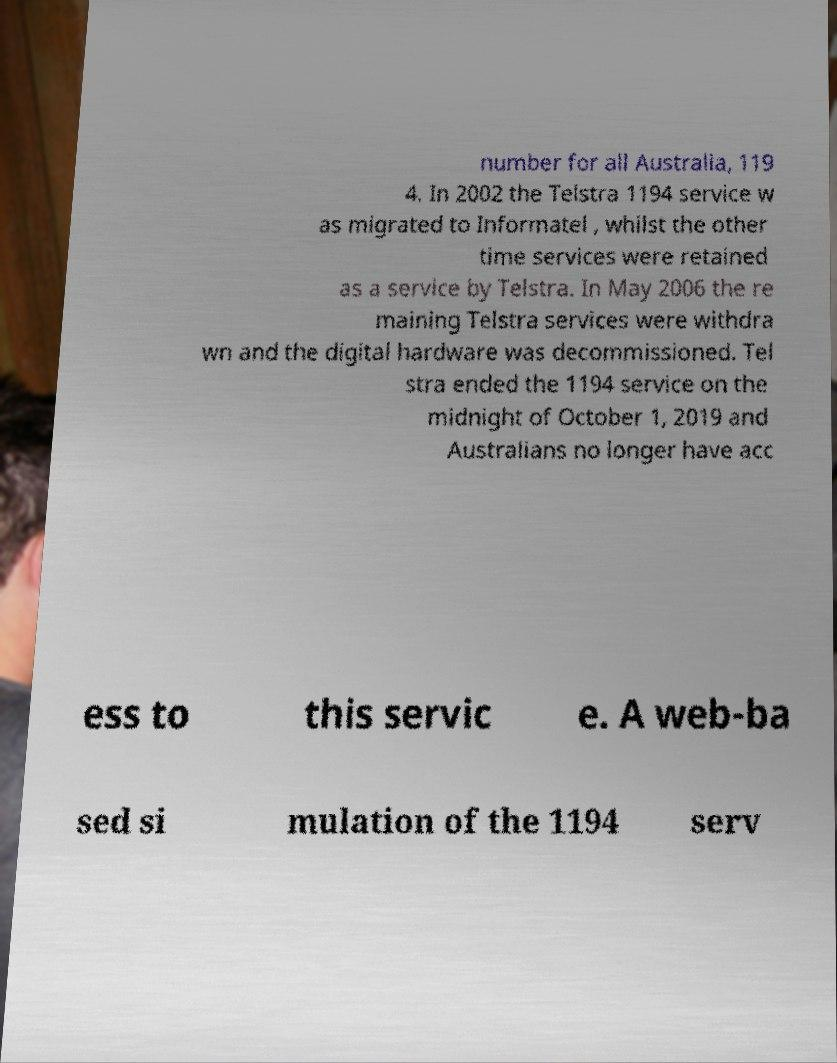Can you read and provide the text displayed in the image?This photo seems to have some interesting text. Can you extract and type it out for me? number for all Australia, 119 4. In 2002 the Telstra 1194 service w as migrated to Informatel , whilst the other time services were retained as a service by Telstra. In May 2006 the re maining Telstra services were withdra wn and the digital hardware was decommissioned. Tel stra ended the 1194 service on the midnight of October 1, 2019 and Australians no longer have acc ess to this servic e. A web-ba sed si mulation of the 1194 serv 